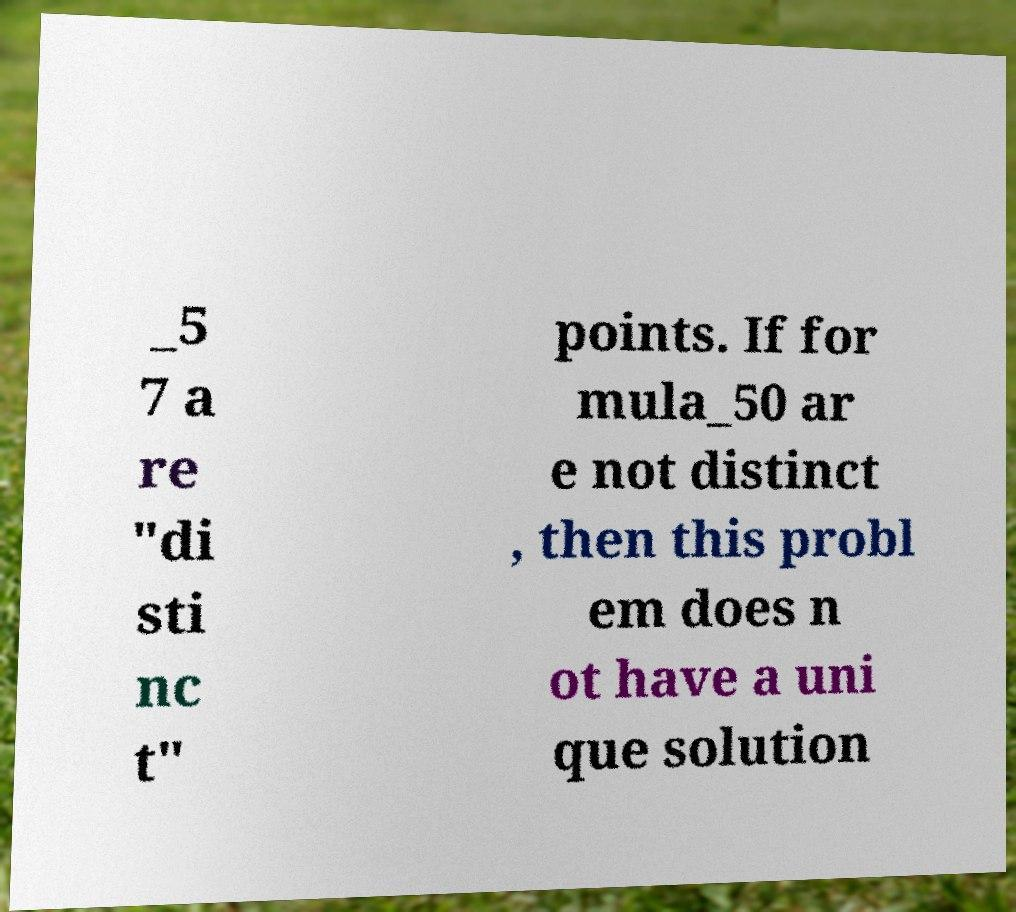Could you assist in decoding the text presented in this image and type it out clearly? _5 7 a re "di sti nc t" points. If for mula_50 ar e not distinct , then this probl em does n ot have a uni que solution 